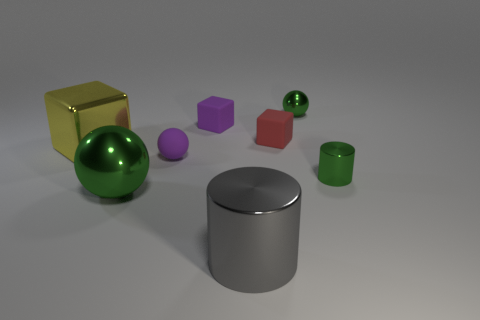Is there any indication of the scale or size of the objects in the image? The image does not provide direct indicators of scale such as familiar objects for comparison or a backdrop with known dimensions. All objects are floating without reference to each other or an environment with recognized parameters, which makes it challenging to determine their actual size or scale with precision. 